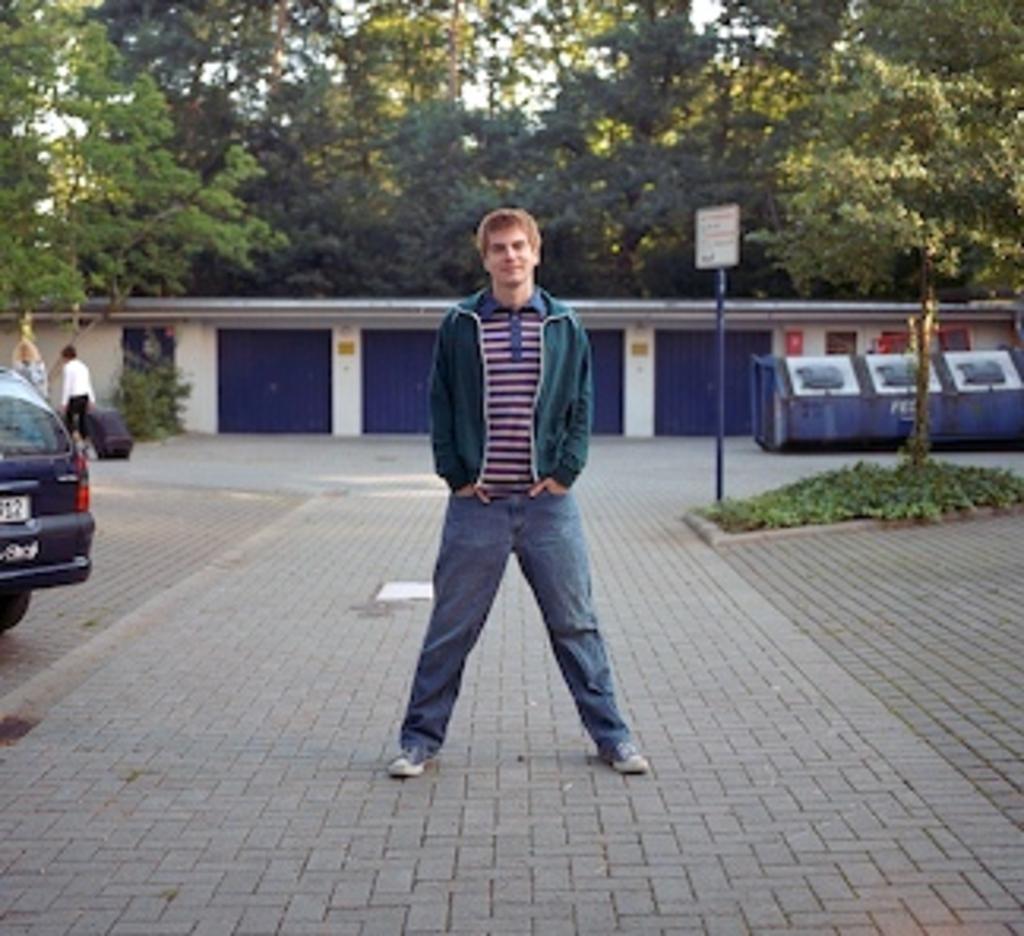Describe this image in one or two sentences. There is a person in blue color jean pant, smiling and standing on the road. On the left side, there is a vehicle parked on the footpath. In the background, there is a person in white color shirt holding a wheel bag and walking on the road, there is a hoarding attached to the pole near plants on the ground, there are shutters, trees and there is sky. 